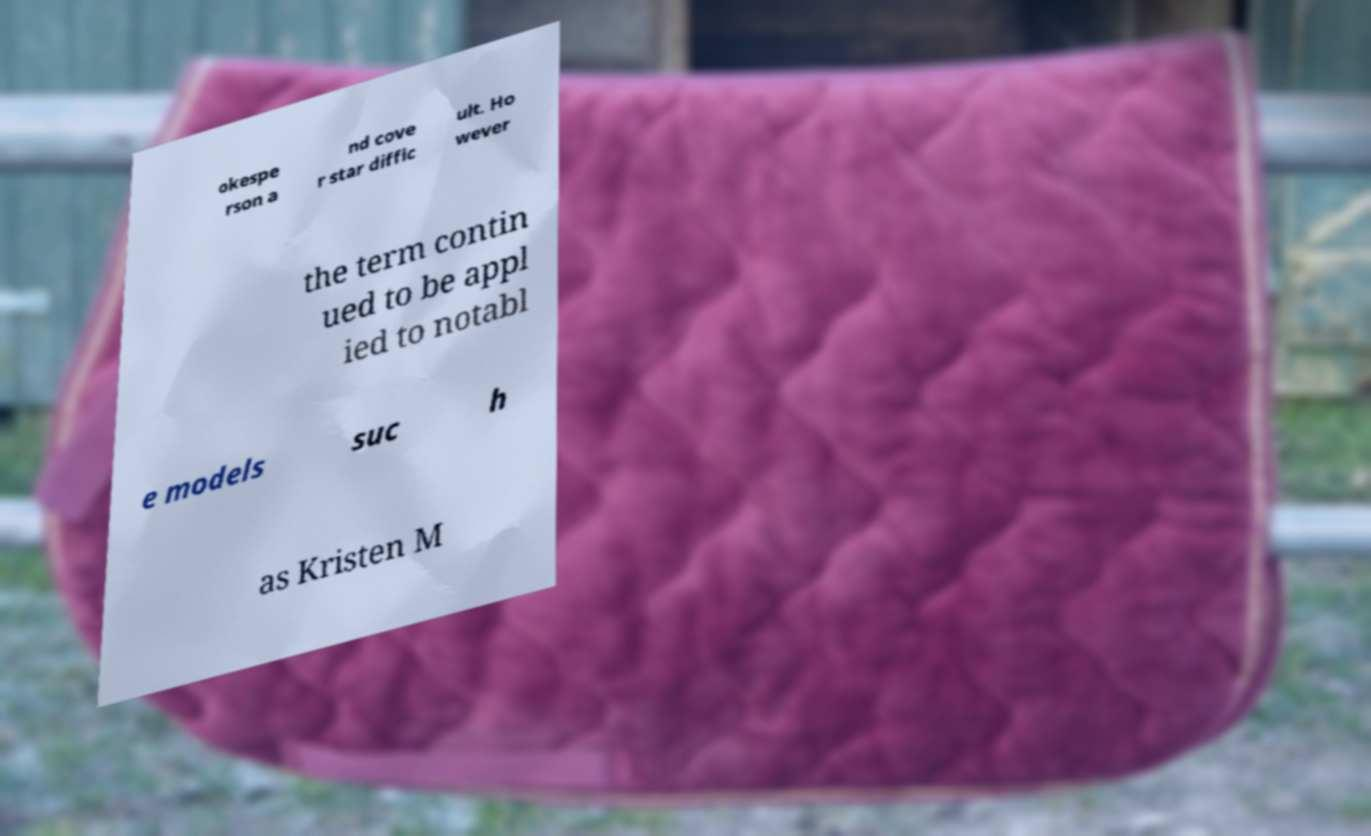What messages or text are displayed in this image? I need them in a readable, typed format. okespe rson a nd cove r star diffic ult. Ho wever the term contin ued to be appl ied to notabl e models suc h as Kristen M 